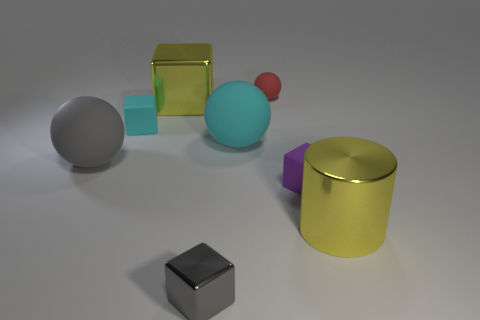Subtract all big metal blocks. How many blocks are left? 3 Subtract all purple blocks. How many blocks are left? 3 Add 1 small matte blocks. How many objects exist? 9 Subtract all red blocks. Subtract all red balls. How many blocks are left? 4 Subtract all spheres. How many objects are left? 5 Subtract 1 cyan blocks. How many objects are left? 7 Subtract all cyan objects. Subtract all small gray metallic blocks. How many objects are left? 5 Add 5 yellow metal blocks. How many yellow metal blocks are left? 6 Add 4 tiny gray objects. How many tiny gray objects exist? 5 